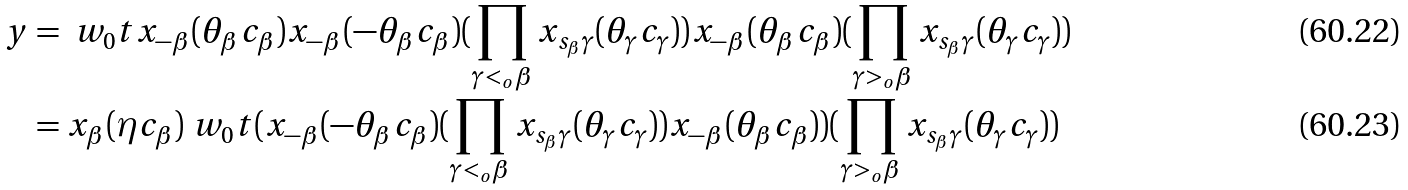<formula> <loc_0><loc_0><loc_500><loc_500>y & = \ w _ { 0 } t x _ { - \beta } ( \theta _ { \beta } c _ { \beta } ) x _ { - \beta } ( - \theta _ { \beta } c _ { \beta } ) ( \prod _ { \gamma < _ { o } \beta } x _ { s _ { \beta } \gamma } ( \theta _ { \gamma } c _ { \gamma } ) ) x _ { - \beta } ( \theta _ { \beta } c _ { \beta } ) ( \prod _ { \gamma > _ { o } \beta } x _ { s _ { \beta } \gamma } ( \theta _ { \gamma } c _ { \gamma } ) ) \\ & = x _ { \beta } ( \eta c _ { \beta } ) \ w _ { 0 } t ( x _ { - \beta } ( - \theta _ { \beta } c _ { \beta } ) ( \prod _ { \gamma < _ { o } \beta } x _ { s _ { \beta } \gamma } ( \theta _ { \gamma } c _ { \gamma } ) ) x _ { - \beta } ( \theta _ { \beta } c _ { \beta } ) ) ( \prod _ { \gamma > _ { o } \beta } x _ { s _ { \beta } \gamma } ( \theta _ { \gamma } c _ { \gamma } ) )</formula> 